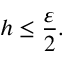<formula> <loc_0><loc_0><loc_500><loc_500>h \leq \frac { \varepsilon } { 2 } .</formula> 